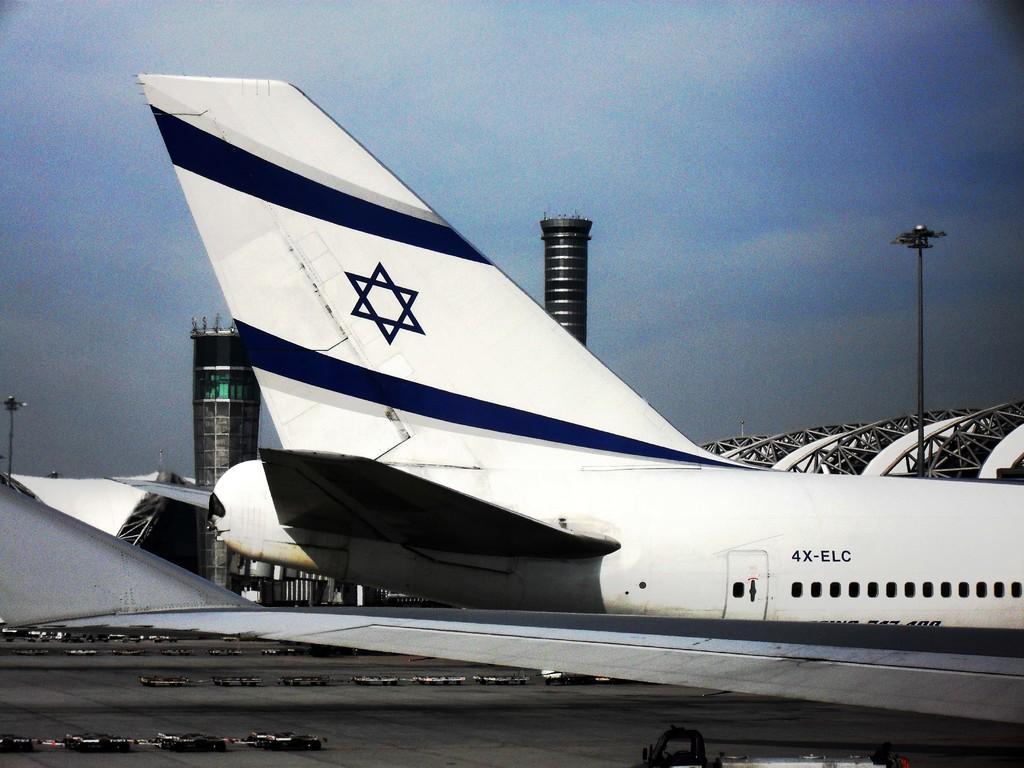How would you summarize this image in a sentence or two? In this image I can see an aeroplane which is in white and blue color and I can see windows,light poles and few objects on the ground. The sky is in white and blue color. 